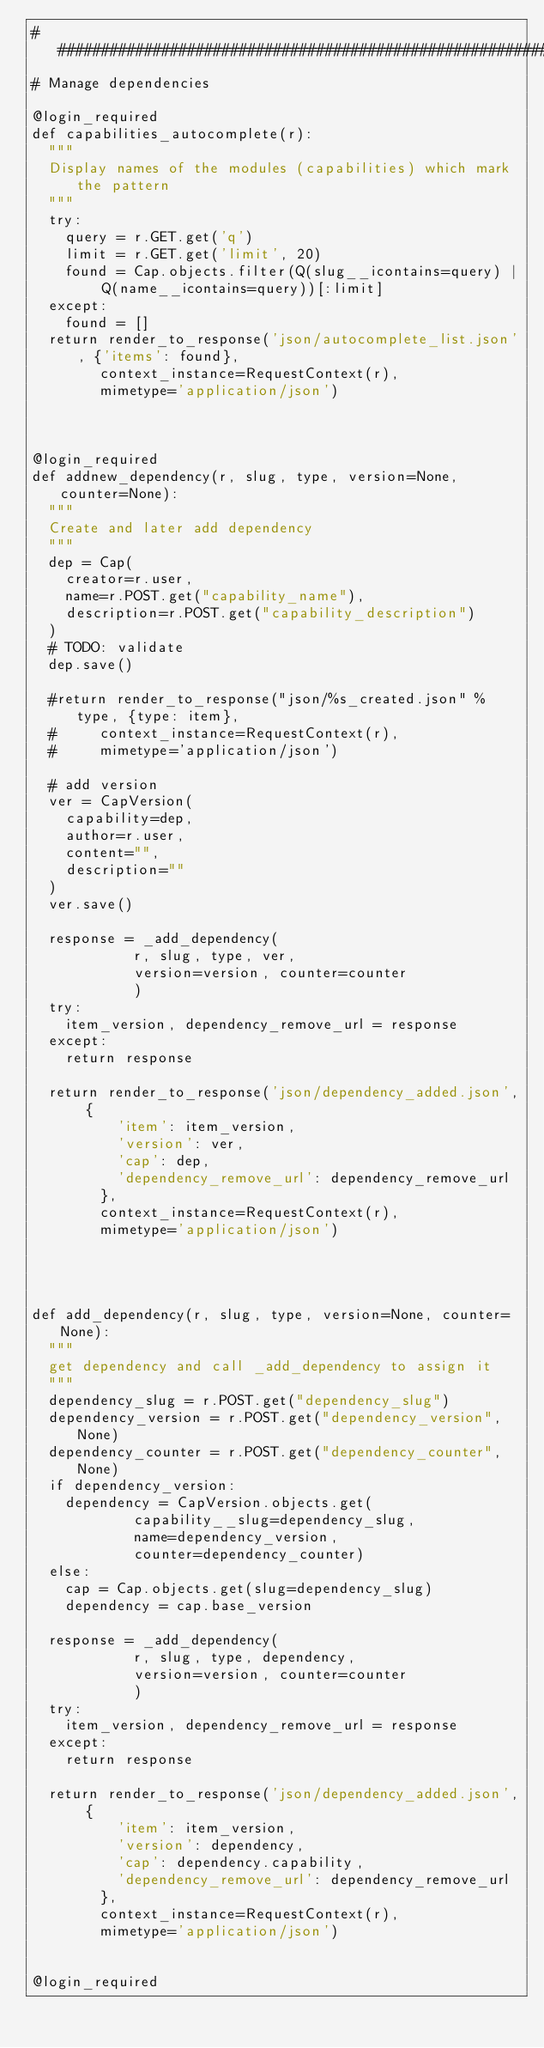<code> <loc_0><loc_0><loc_500><loc_500><_Python_>##########################################################
# Manage dependencies

@login_required
def capabilities_autocomplete(r):
	"""
	Display names of the modules (capabilities) which mark the pattern
	"""
	try:
		query = r.GET.get('q')
		limit = r.GET.get('limit', 20)
		found = Cap.objects.filter(Q(slug__icontains=query) | Q(name__icontains=query))[:limit]
	except:
		found = []
	return render_to_response('json/autocomplete_list.json', {'items': found},
				context_instance=RequestContext(r),
				mimetype='application/json')
	

	
@login_required
def addnew_dependency(r, slug, type, version=None, counter=None):
	"""
	Create and later add dependency
	"""
	dep = Cap(
		creator=r.user,
		name=r.POST.get("capability_name"),
		description=r.POST.get("capability_description")
	)
	# TODO: validate
	dep.save()

	#return render_to_response("json/%s_created.json" % type, {type: item},
	#			context_instance=RequestContext(r),
	#			mimetype='application/json')
	
	# add version
	ver = CapVersion(
		capability=dep,
		author=r.user,
		content="",
		description=""
	) 
	ver.save()
	
	response = _add_dependency(
						r, slug, type, ver,
						version=version, counter=counter
						)
	try: 
		item_version, dependency_remove_url = response
	except:
		return response

	return render_to_response('json/dependency_added.json', {
					'item': item_version, 
					'version': ver, 
					'cap': dep,
					'dependency_remove_url': dependency_remove_url
				},
				context_instance=RequestContext(r),
				mimetype='application/json')


	
	
def add_dependency(r, slug, type, version=None, counter=None):
	"""
	get dependency and call _add_dependency to assign it
	"""
	dependency_slug = r.POST.get("dependency_slug")
	dependency_version = r.POST.get("dependency_version", None)
	dependency_counter = r.POST.get("dependency_counter", None)
	if dependency_version:
		dependency = CapVersion.objects.get(
						capability__slug=dependency_slug, 
						name=dependency_version, 
						counter=dependency_counter)
	else:
		cap = Cap.objects.get(slug=dependency_slug)
		dependency = cap.base_version
	
	response = _add_dependency(
						r, slug, type, dependency,
						version=version, counter=counter
						)
	try: 
		item_version, dependency_remove_url = response
	except:
		return response

	return render_to_response('json/dependency_added.json', {
					'item': item_version, 
					'version': dependency, 
					'cap': dependency.capability,
					'dependency_remove_url': dependency_remove_url
				},
				context_instance=RequestContext(r),
				mimetype='application/json')


@login_required</code> 